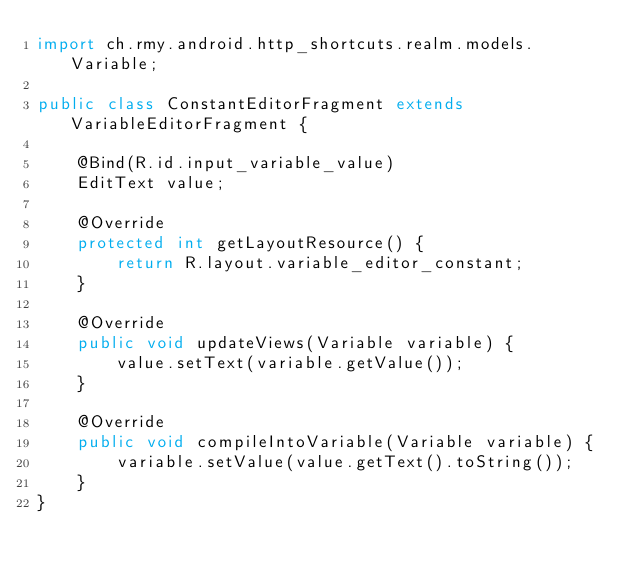Convert code to text. <code><loc_0><loc_0><loc_500><loc_500><_Java_>import ch.rmy.android.http_shortcuts.realm.models.Variable;

public class ConstantEditorFragment extends VariableEditorFragment {

    @Bind(R.id.input_variable_value)
    EditText value;

    @Override
    protected int getLayoutResource() {
        return R.layout.variable_editor_constant;
    }

    @Override
    public void updateViews(Variable variable) {
        value.setText(variable.getValue());
    }

    @Override
    public void compileIntoVariable(Variable variable) {
        variable.setValue(value.getText().toString());
    }
}
</code> 